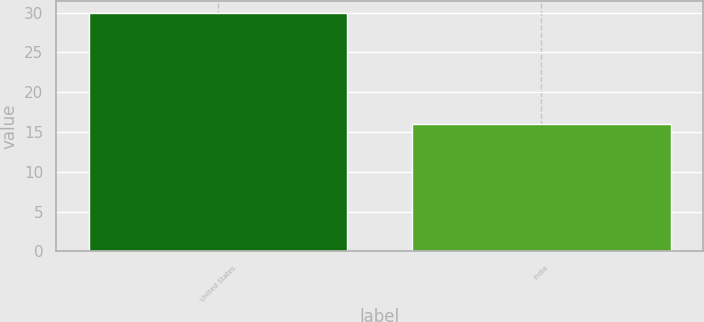Convert chart. <chart><loc_0><loc_0><loc_500><loc_500><bar_chart><fcel>United States<fcel>India<nl><fcel>30<fcel>16<nl></chart> 